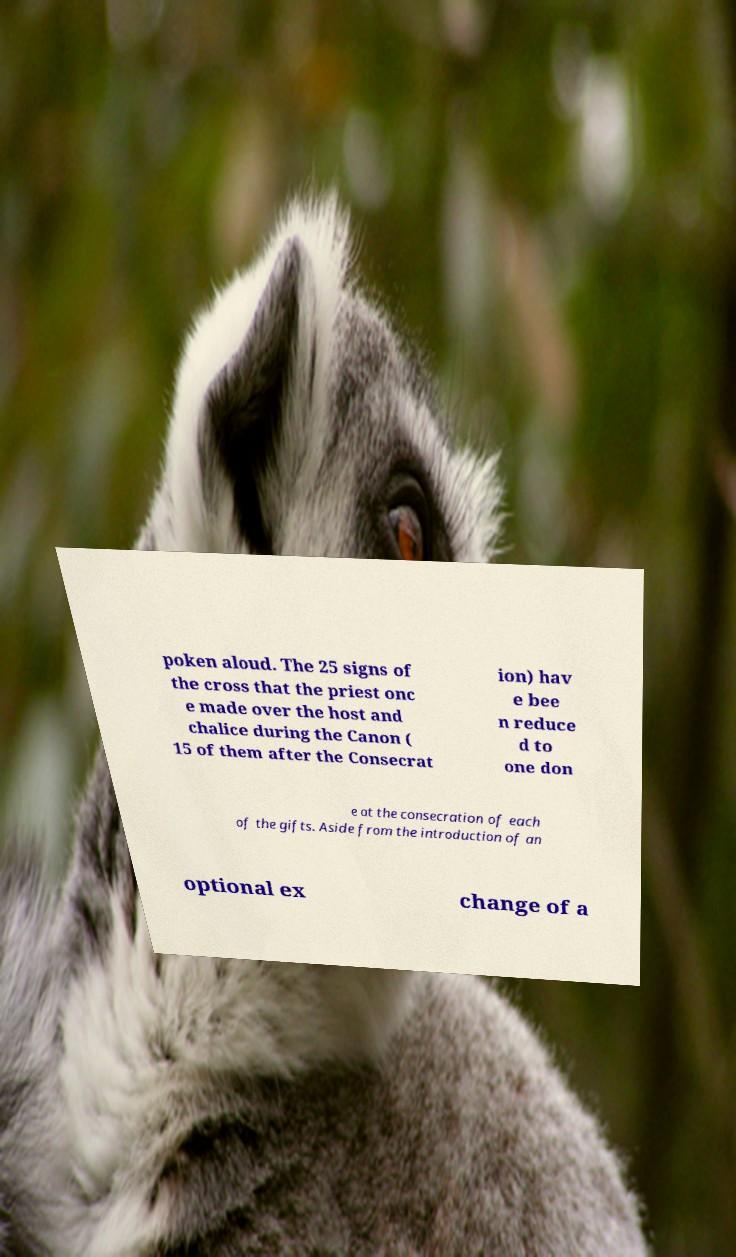Please read and relay the text visible in this image. What does it say? poken aloud. The 25 signs of the cross that the priest onc e made over the host and chalice during the Canon ( 15 of them after the Consecrat ion) hav e bee n reduce d to one don e at the consecration of each of the gifts. Aside from the introduction of an optional ex change of a 